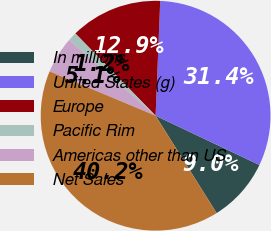Convert chart. <chart><loc_0><loc_0><loc_500><loc_500><pie_chart><fcel>In millions<fcel>United States (g)<fcel>Europe<fcel>Pacific Rim<fcel>Americas other than US<fcel>Net Sales<nl><fcel>9.04%<fcel>31.41%<fcel>12.94%<fcel>1.25%<fcel>5.14%<fcel>40.22%<nl></chart> 